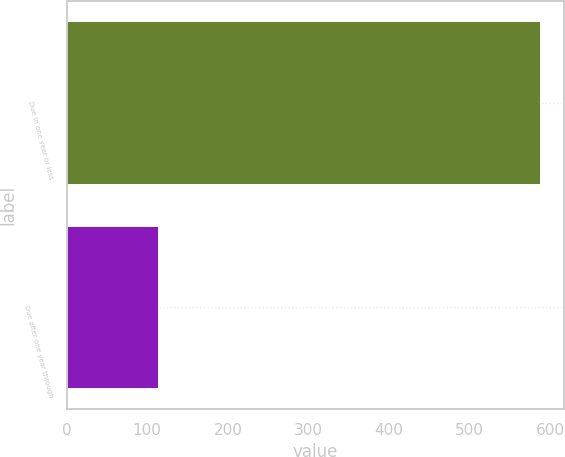Convert chart. <chart><loc_0><loc_0><loc_500><loc_500><bar_chart><fcel>Due in one year or less<fcel>Due after one year through<nl><fcel>588<fcel>114<nl></chart> 